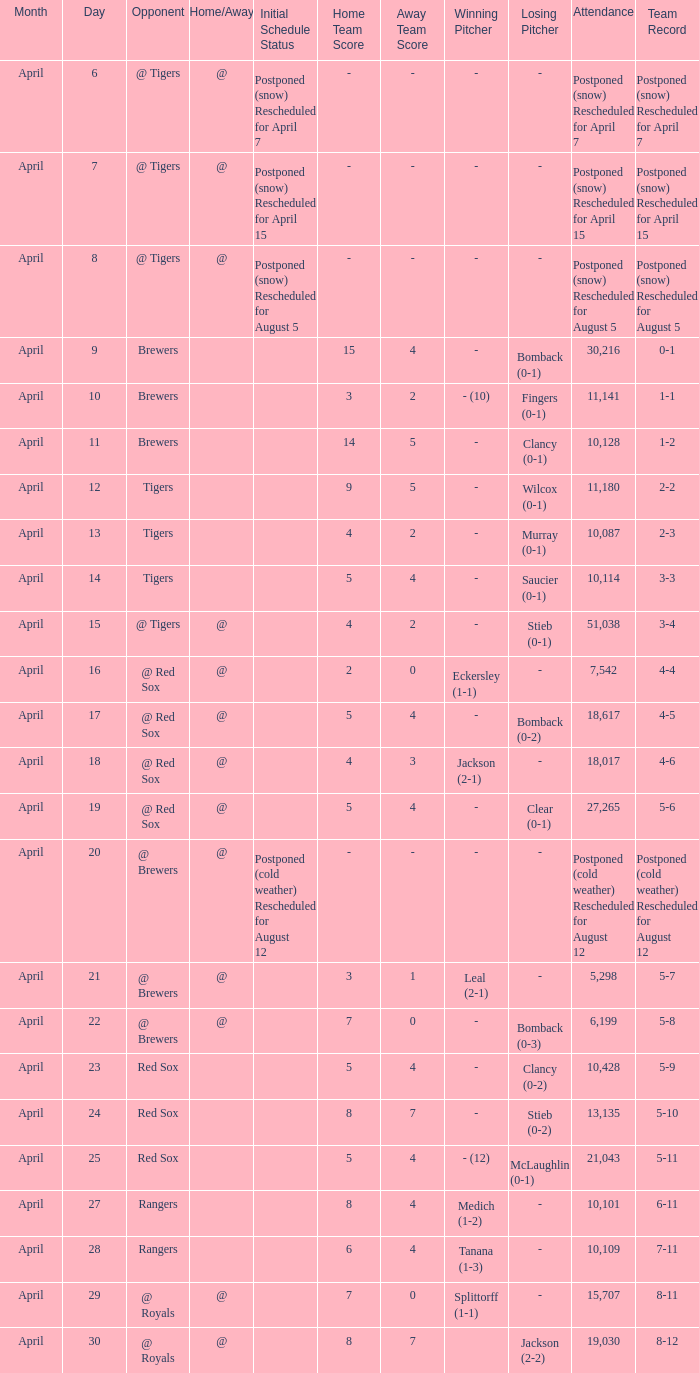Can you give me this table as a dict? {'header': ['Month', 'Day', 'Opponent', 'Home/Away', 'Initial Schedule Status', 'Home Team Score', 'Away Team Score', 'Winning Pitcher', 'Losing Pitcher', 'Attendance', 'Team Record'], 'rows': [['April', '6', '@ Tigers', '@', 'Postponed (snow) Rescheduled for April 7', '-', '-', '-', '-', 'Postponed (snow) Rescheduled for April 7', 'Postponed (snow) Rescheduled for April 7'], ['April', '7', '@ Tigers', '@', 'Postponed (snow) Rescheduled for April 15', '-', '-', '-', '-', 'Postponed (snow) Rescheduled for April 15', 'Postponed (snow) Rescheduled for April 15'], ['April', '8', '@ Tigers', '@', 'Postponed (snow) Rescheduled for August 5', '-', '-', '-', '-', 'Postponed (snow) Rescheduled for August 5', 'Postponed (snow) Rescheduled for August 5'], ['April', '9', 'Brewers', '', '', '15', '4', '-', 'Bomback (0-1)', '30,216', '0-1'], ['April', '10', 'Brewers', '', '', '3', '2', '- (10)', 'Fingers (0-1)', '11,141', '1-1'], ['April', '11', 'Brewers', '', '', '14', '5', '-', 'Clancy (0-1)', '10,128', '1-2'], ['April', '12', 'Tigers', '', '', '9', '5', '-', 'Wilcox (0-1)', '11,180', '2-2'], ['April', '13', 'Tigers', '', '', '4', '2', '-', 'Murray (0-1)', '10,087', '2-3'], ['April', '14', 'Tigers', '', '', '5', '4', '-', 'Saucier (0-1)', '10,114', '3-3'], ['April', '15', '@ Tigers', '@', '', '4', '2', '-', 'Stieb (0-1)', '51,038', '3-4'], ['April', '16', '@ Red Sox', '@', '', '2', '0', 'Eckersley (1-1)', '-', '7,542', '4-4'], ['April', '17', '@ Red Sox', '@', '', '5', '4', '-', 'Bomback (0-2)', '18,617', '4-5'], ['April', '18', '@ Red Sox', '@', '', '4', '3', 'Jackson (2-1)', '-', '18,017', '4-6'], ['April', '19', '@ Red Sox', '@', '', '5', '4', '-', 'Clear (0-1)', '27,265', '5-6'], ['April', '20', '@ Brewers', '@', 'Postponed (cold weather) Rescheduled for August 12', '-', '-', '-', '-', 'Postponed (cold weather) Rescheduled for August 12', 'Postponed (cold weather) Rescheduled for August 12'], ['April', '21', '@ Brewers', '@', '', '3', '1', 'Leal (2-1)', '-', '5,298', '5-7'], ['April', '22', '@ Brewers', '@', '', '7', '0', '-', 'Bomback (0-3)', '6,199', '5-8'], ['April', '23', 'Red Sox', '', '', '5', '4', '-', 'Clancy (0-2)', '10,428', '5-9'], ['April', '24', 'Red Sox', '', '', '8', '7', '-', 'Stieb (0-2)', '13,135', '5-10'], ['April', '25', 'Red Sox', '', '', '5', '4', '- (12)', 'McLaughlin (0-1)', '21,043', '5-11'], ['April', '27', 'Rangers', '', '', '8', '4', 'Medich (1-2)', '-', '10,101', '6-11'], ['April', '28', 'Rangers', '', '', '6', '4', 'Tanana (1-3)', '-', '10,109', '7-11'], ['April', '29', '@ Royals', '@', '', '7', '0', 'Splittorff (1-1)', '-', '15,707', '8-11'], ['April', '30', '@ Royals', '@', '', '8', '7', '', 'Jackson (2-2)', '19,030', '8-12']]} What is the score for the game that has an attendance of 5,298? 3 - 1. 